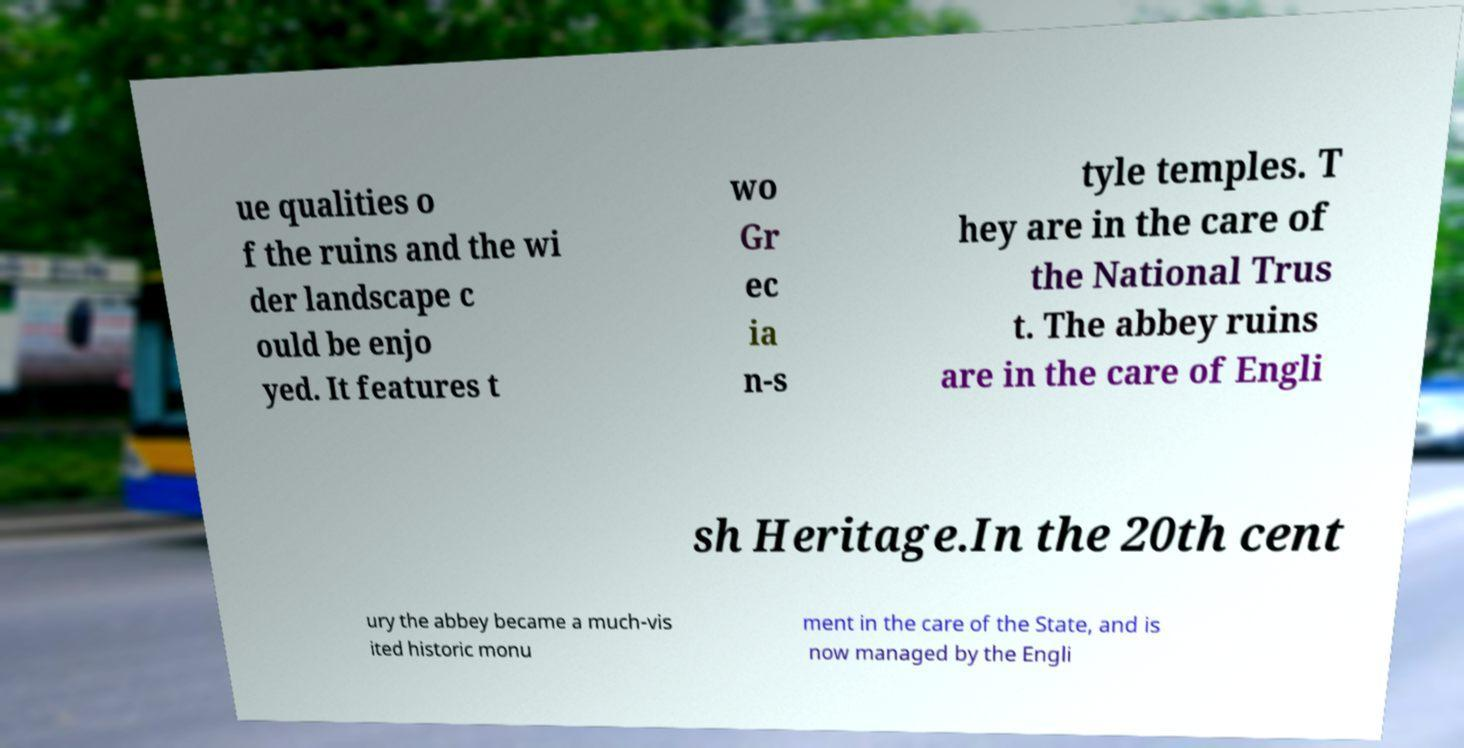Could you assist in decoding the text presented in this image and type it out clearly? ue qualities o f the ruins and the wi der landscape c ould be enjo yed. It features t wo Gr ec ia n-s tyle temples. T hey are in the care of the National Trus t. The abbey ruins are in the care of Engli sh Heritage.In the 20th cent ury the abbey became a much-vis ited historic monu ment in the care of the State, and is now managed by the Engli 